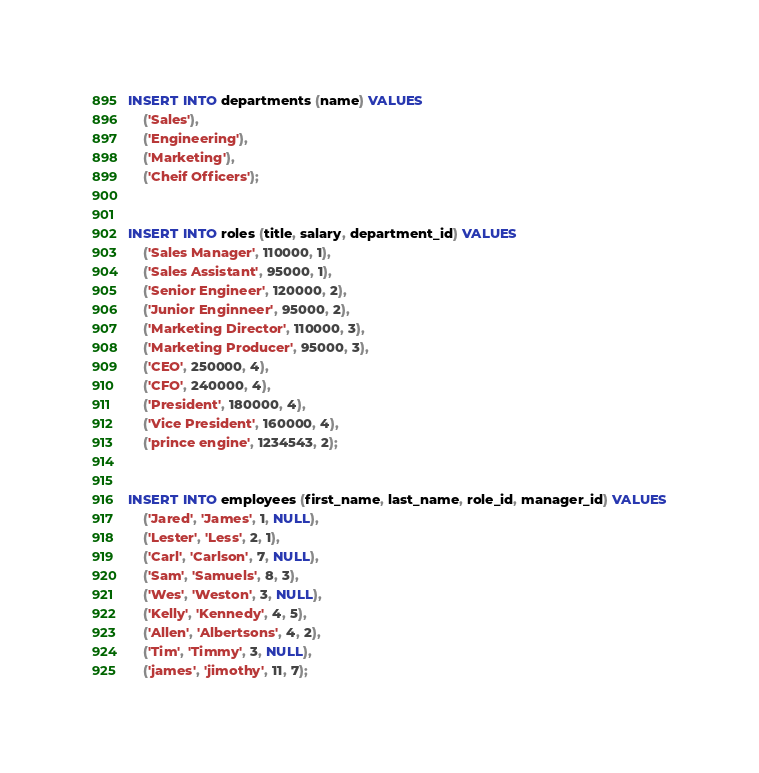Convert code to text. <code><loc_0><loc_0><loc_500><loc_500><_SQL_>
INSERT INTO departments (name) VALUES
    ('Sales'),
    ('Engineering'),
    ('Marketing'),
    ('Cheif Officers');
    

INSERT INTO roles (title, salary, department_id) VALUES
    ('Sales Manager', 110000, 1),
    ('Sales Assistant', 95000, 1),
    ('Senior Engineer', 120000, 2),
    ('Junior Enginneer', 95000, 2),
    ('Marketing Director', 110000, 3),
    ('Marketing Producer', 95000, 3),
    ('CEO', 250000, 4),
    ('CFO', 240000, 4),
    ('President', 180000, 4),
    ('Vice President', 160000, 4),
    ('prince engine', 1234543, 2);


INSERT INTO employees (first_name, last_name, role_id, manager_id) VALUES
    ('Jared', 'James', 1, NULL),
    ('Lester', 'Less', 2, 1),
    ('Carl', 'Carlson', 7, NULL),
    ('Sam', 'Samuels', 8, 3),
    ('Wes', 'Weston', 3, NULL),
    ('Kelly', 'Kennedy', 4, 5),
    ('Allen', 'Albertsons', 4, 2),
    ('Tim', 'Timmy', 3, NULL),
    ('james', 'jimothy', 11, 7);
</code> 